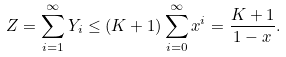Convert formula to latex. <formula><loc_0><loc_0><loc_500><loc_500>Z = \sum _ { i = 1 } ^ { \infty } Y _ { i } \leq ( K + 1 ) \sum _ { i = 0 } ^ { \infty } x ^ { i } = \frac { K + 1 } { 1 - x } .</formula> 